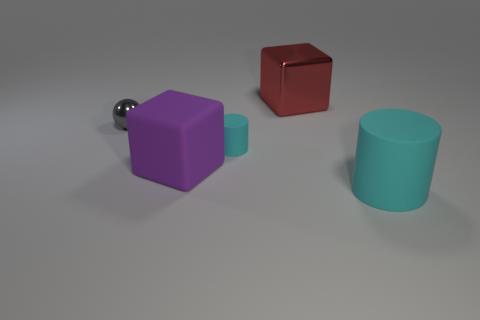Is there any other thing of the same color as the big cylinder?
Give a very brief answer. Yes. Is the number of purple cubes on the left side of the small matte thing greater than the number of gray metallic balls that are to the right of the large cylinder?
Your response must be concise. Yes. What number of red blocks are the same size as the metallic ball?
Make the answer very short. 0. Are there fewer big cyan rubber objects that are behind the tiny cyan matte object than red metallic objects that are in front of the gray thing?
Make the answer very short. No. Are there any tiny objects that have the same shape as the big cyan object?
Make the answer very short. Yes. Do the red thing and the purple object have the same shape?
Give a very brief answer. Yes. How many large things are either shiny objects or matte cylinders?
Offer a very short reply. 2. Are there more large red metallic cylinders than tiny spheres?
Make the answer very short. No. What is the size of the red block that is made of the same material as the gray object?
Provide a succinct answer. Large. There is a cyan rubber cylinder behind the big cyan cylinder; is it the same size as the thing that is in front of the big purple matte thing?
Offer a very short reply. No. 